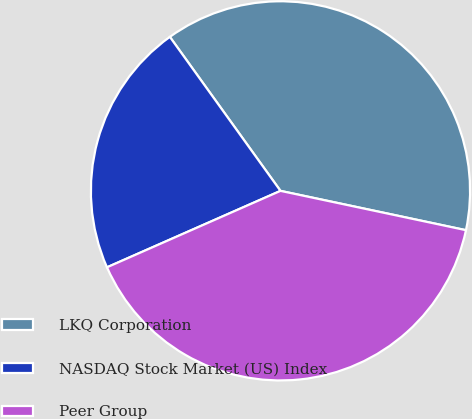Convert chart to OTSL. <chart><loc_0><loc_0><loc_500><loc_500><pie_chart><fcel>LKQ Corporation<fcel>NASDAQ Stock Market (US) Index<fcel>Peer Group<nl><fcel>38.24%<fcel>21.69%<fcel>40.07%<nl></chart> 